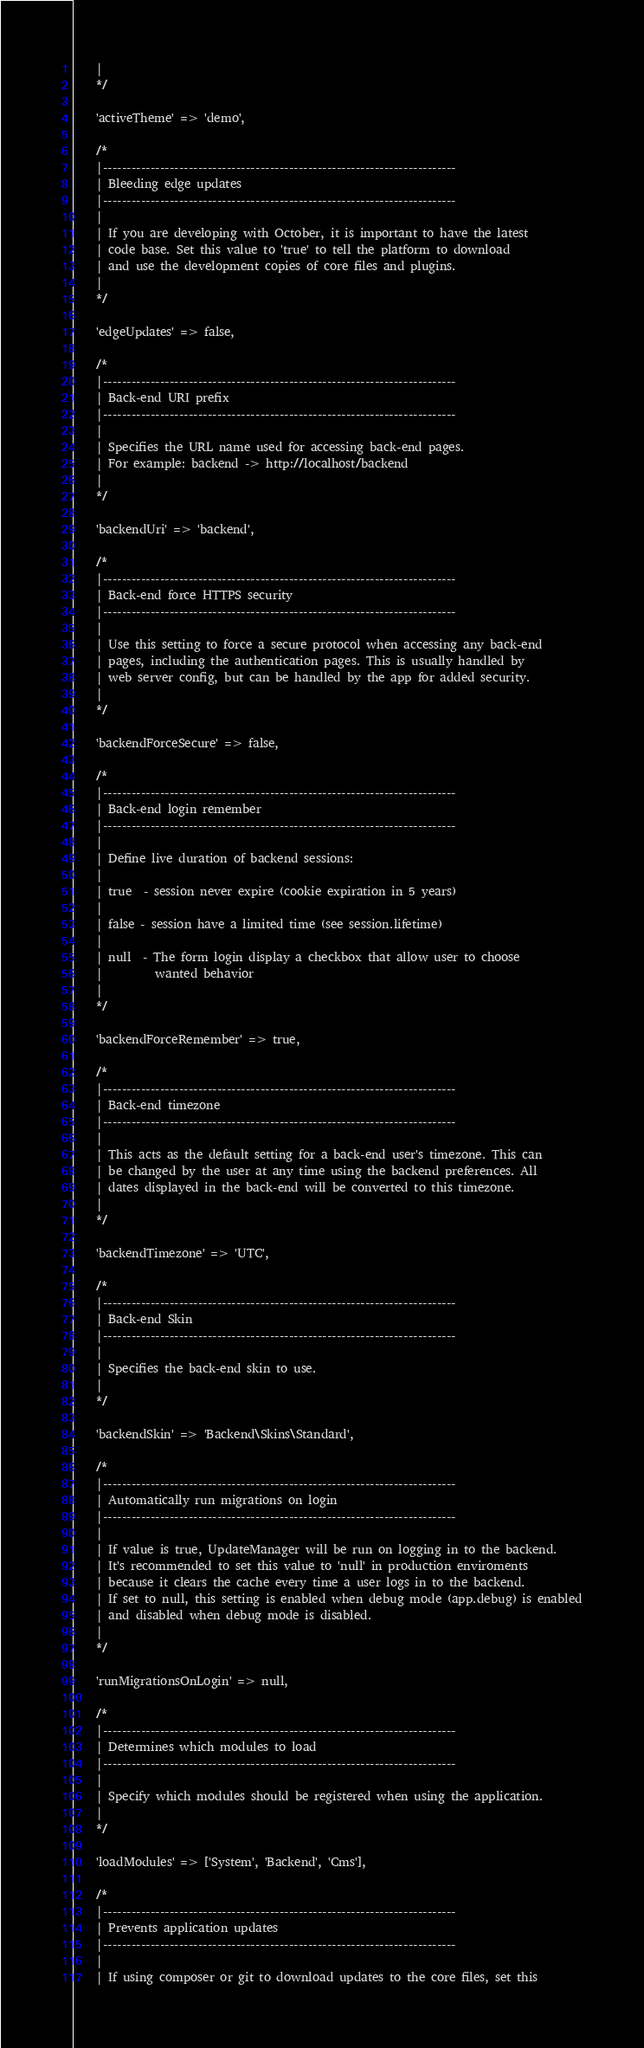<code> <loc_0><loc_0><loc_500><loc_500><_PHP_>    |
    */

    'activeTheme' => 'demo',

    /*
    |--------------------------------------------------------------------------
    | Bleeding edge updates
    |--------------------------------------------------------------------------
    |
    | If you are developing with October, it is important to have the latest
    | code base. Set this value to 'true' to tell the platform to download
    | and use the development copies of core files and plugins.
    |
    */

    'edgeUpdates' => false,

    /*
    |--------------------------------------------------------------------------
    | Back-end URI prefix
    |--------------------------------------------------------------------------
    |
    | Specifies the URL name used for accessing back-end pages.
    | For example: backend -> http://localhost/backend
    |
    */

    'backendUri' => 'backend',

    /*
    |--------------------------------------------------------------------------
    | Back-end force HTTPS security
    |--------------------------------------------------------------------------
    |
    | Use this setting to force a secure protocol when accessing any back-end
    | pages, including the authentication pages. This is usually handled by
    | web server config, but can be handled by the app for added security.
    |
    */

    'backendForceSecure' => false,

    /*
    |--------------------------------------------------------------------------
    | Back-end login remember
    |--------------------------------------------------------------------------
    |
    | Define live duration of backend sessions:
    |
    | true  - session never expire (cookie expiration in 5 years)
    |
    | false - session have a limited time (see session.lifetime)
    |
    | null  - The form login display a checkbox that allow user to choose
    |         wanted behavior
    |
    */

    'backendForceRemember' => true,

    /*
    |--------------------------------------------------------------------------
    | Back-end timezone
    |--------------------------------------------------------------------------
    |
    | This acts as the default setting for a back-end user's timezone. This can
    | be changed by the user at any time using the backend preferences. All
    | dates displayed in the back-end will be converted to this timezone.
    |
    */

    'backendTimezone' => 'UTC',

    /*
    |--------------------------------------------------------------------------
    | Back-end Skin
    |--------------------------------------------------------------------------
    |
    | Specifies the back-end skin to use.
    |
    */

    'backendSkin' => 'Backend\Skins\Standard',

    /*
    |--------------------------------------------------------------------------
    | Automatically run migrations on login
    |--------------------------------------------------------------------------
    |
    | If value is true, UpdateManager will be run on logging in to the backend.
    | It's recommended to set this value to 'null' in production enviroments
    | because it clears the cache every time a user logs in to the backend.
    | If set to null, this setting is enabled when debug mode (app.debug) is enabled
    | and disabled when debug mode is disabled.
    |
    */

    'runMigrationsOnLogin' => null,

    /*
    |--------------------------------------------------------------------------
    | Determines which modules to load
    |--------------------------------------------------------------------------
    |
    | Specify which modules should be registered when using the application.
    |
    */

    'loadModules' => ['System', 'Backend', 'Cms'],

    /*
    |--------------------------------------------------------------------------
    | Prevents application updates
    |--------------------------------------------------------------------------
    |
    | If using composer or git to download updates to the core files, set this</code> 